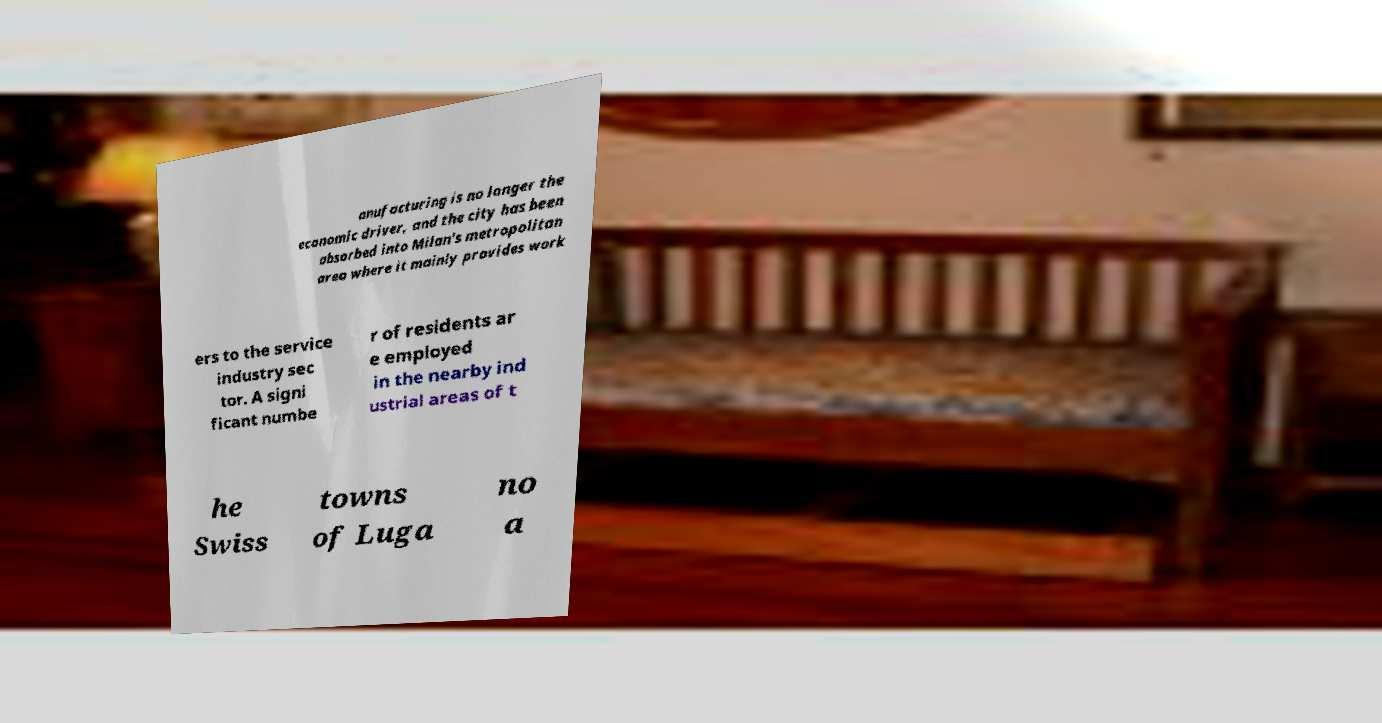There's text embedded in this image that I need extracted. Can you transcribe it verbatim? anufacturing is no longer the economic driver, and the city has been absorbed into Milan's metropolitan area where it mainly provides work ers to the service industry sec tor. A signi ficant numbe r of residents ar e employed in the nearby ind ustrial areas of t he Swiss towns of Luga no a 